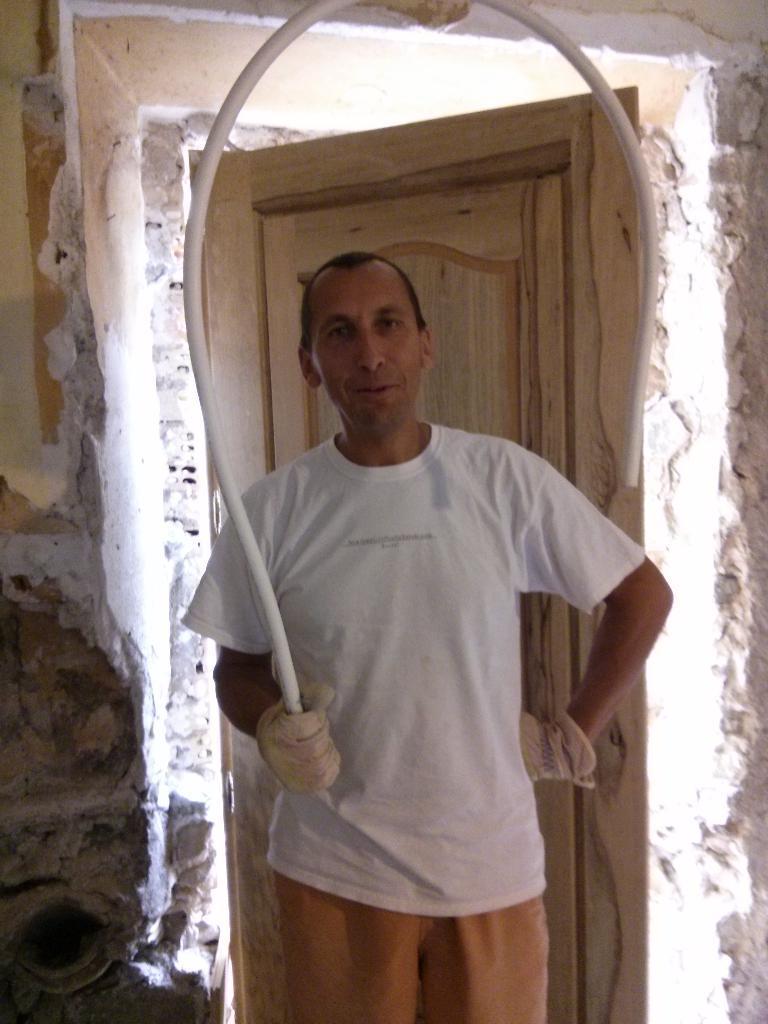Could you give a brief overview of what you see in this image? In the foreground of this image, there is a man standing and wearing gloves and holding a u shaped pipe like an object. In the background, there is a wooden door and the wall. 